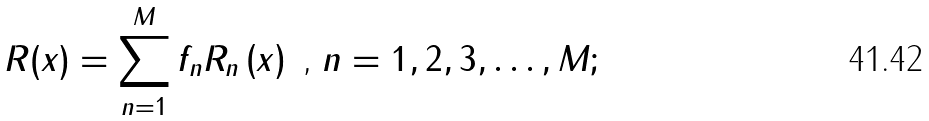Convert formula to latex. <formula><loc_0><loc_0><loc_500><loc_500>R ( x ) = \sum _ { n = 1 } ^ { M } f _ { n } R _ { n } \left ( x \right ) \text { , } n = 1 , 2 , 3 , \dots , M ;</formula> 